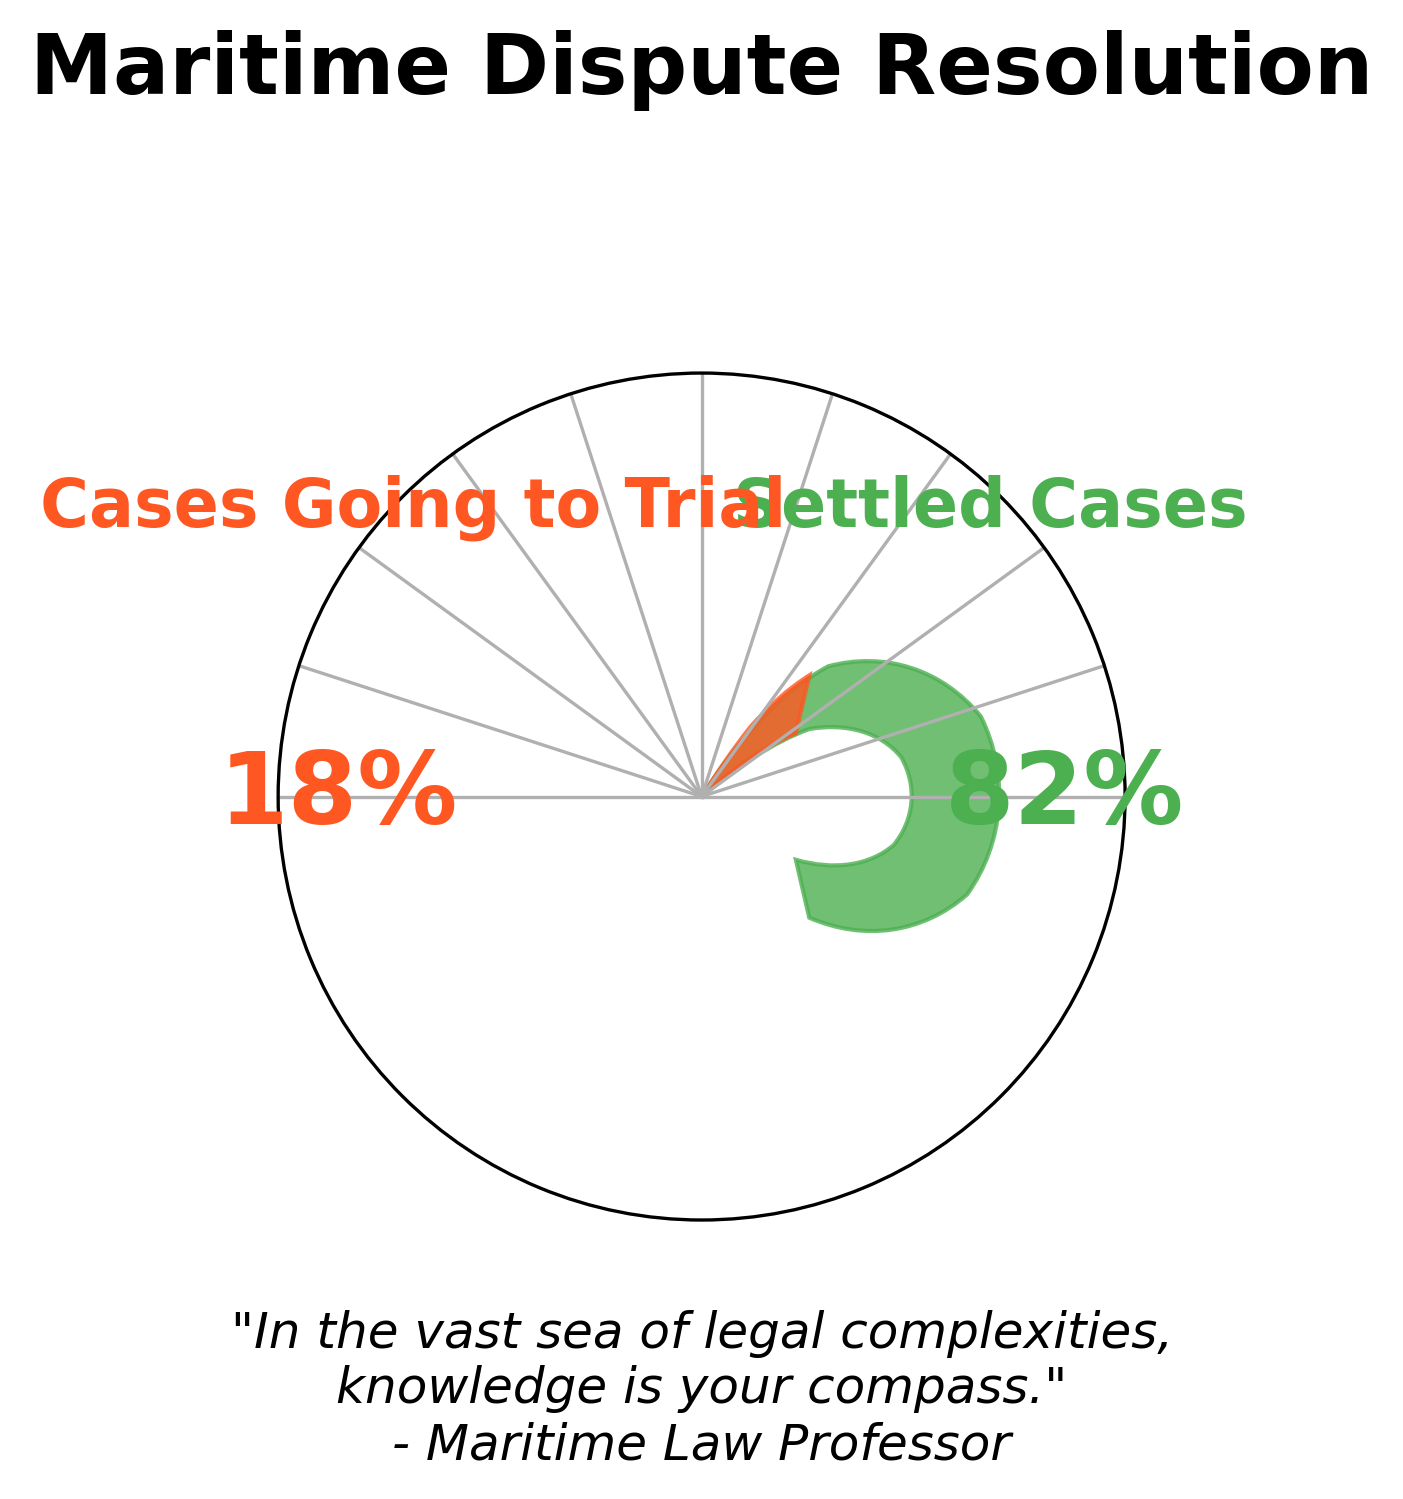What percentage of maritime disputes are settled out of court? The gauge chart shows a segment labeled for settled cases, which indicates the percentage visually. The text annotation near this segment reads "82%".
Answer: 82% What percentage of maritime disputes go to trial? The gauge chart shows a segment labeled for cases going to trial, which indicates the percentage visually. The text annotation near this segment reads "18%".
Answer: 18% Which category has a higher percentage, settled cases or cases going to trial? The gauge chart has two segments, one for settled cases and one for cases going to trial. The settled cases segment is labeled as 82%, and the cases going to trial segment is labeled as 18%. Since 82% is greater than 18%, settled cases have a higher percentage.
Answer: Settled cases By how much does the percentage of settled cases exceed the percentage of cases going to trial? The percentage of settled cases is 82% and the percentage of cases going to trial is 18%. The difference is calculated as 82% - 18%.
Answer: 64% What is the title of the gauge chart? The title is displayed at the top of the chart and reads "Maritime Dispute Resolution".
Answer: Maritime Dispute Resolution How are the percentage values for settled cases and cases going to trial displayed? The percentage values for settled cases and cases going to trial are displayed as text annotations near their respective gauge segments on the chart.
Answer: As text annotations What colors are used to represent settled cases and cases going to trial? The color used for the settled cases segment is green (shades of #4CAF50), and the color for cases going to trial is red (shades of #FF5722).
Answer: Green and Red What is the visual difference between segments representing settled cases and cases going to trial? The segment representing settled cases is larger than the segment representing cases going to trial, indicating a higher percentage. Additionally, the settled cases segment is green, and the cases going to trial segment is red.
Answer: Size and Color What is the motivational quote displayed in the chart? The quote is displayed at the bottom of the chart and reads: "In the vast sea of legal complexities, knowledge is your compass." - Maritime Law Professor.
Answer: "In the vast sea of legal complexities, knowledge is your compass." - Maritime Law Professor 